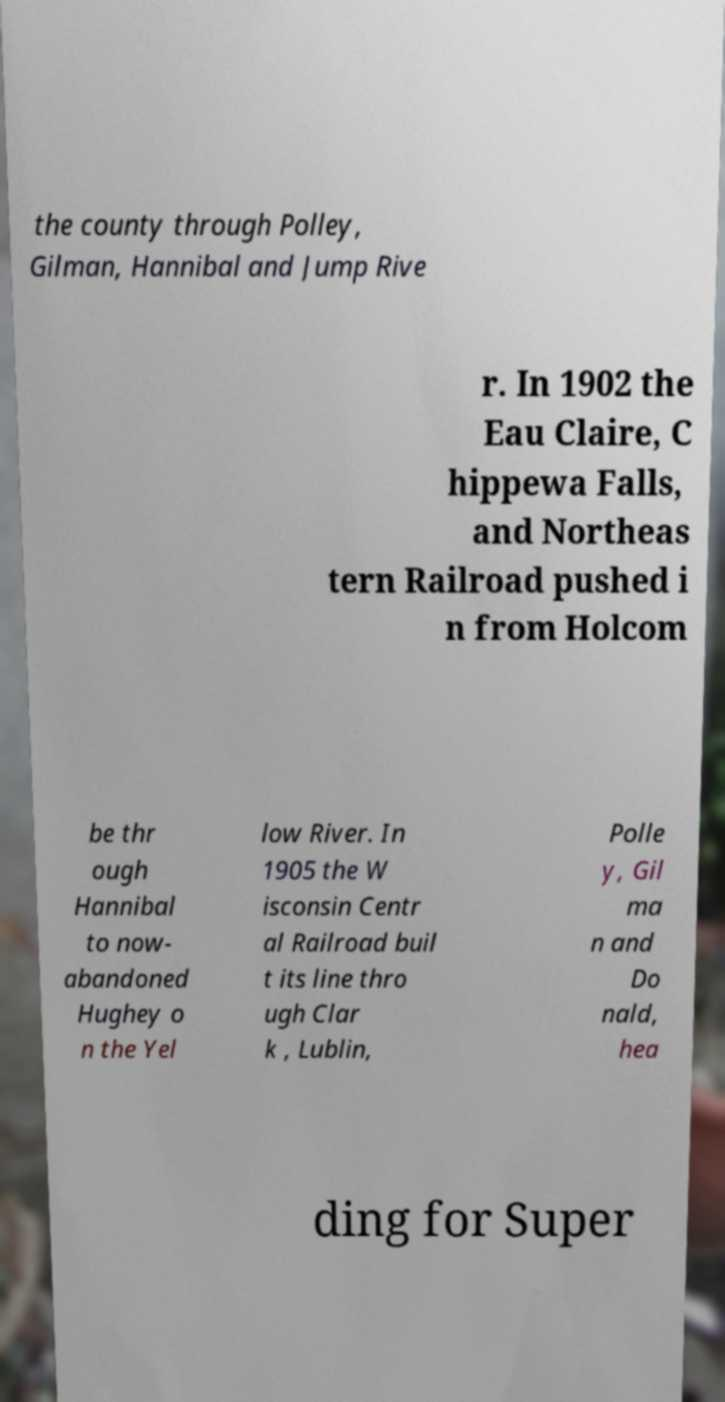What messages or text are displayed in this image? I need them in a readable, typed format. the county through Polley, Gilman, Hannibal and Jump Rive r. In 1902 the Eau Claire, C hippewa Falls, and Northeas tern Railroad pushed i n from Holcom be thr ough Hannibal to now- abandoned Hughey o n the Yel low River. In 1905 the W isconsin Centr al Railroad buil t its line thro ugh Clar k , Lublin, Polle y, Gil ma n and Do nald, hea ding for Super 